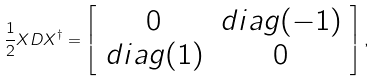<formula> <loc_0><loc_0><loc_500><loc_500>\frac { 1 } { 2 } X D X ^ { \dagger } = \left [ \begin{array} { c c } 0 & d i a g ( - 1 ) \\ d i a g ( 1 ) & 0 \end{array} \right ] ,</formula> 